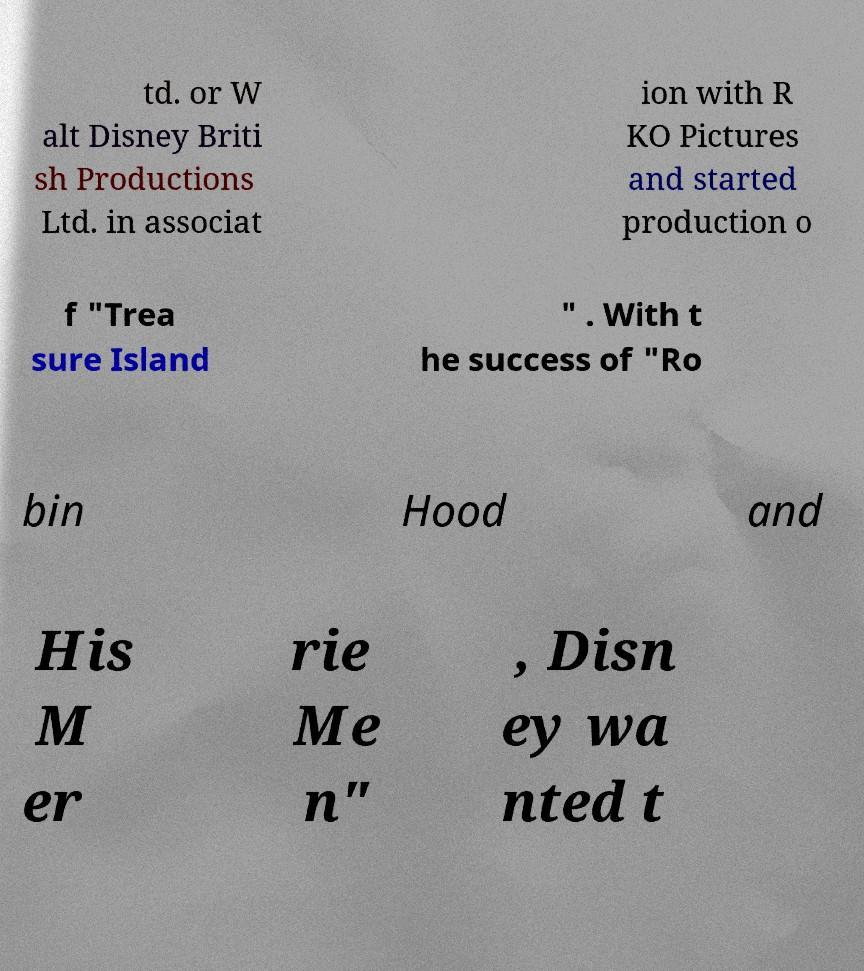Please identify and transcribe the text found in this image. td. or W alt Disney Briti sh Productions Ltd. in associat ion with R KO Pictures and started production o f "Trea sure Island " . With t he success of "Ro bin Hood and His M er rie Me n" , Disn ey wa nted t 